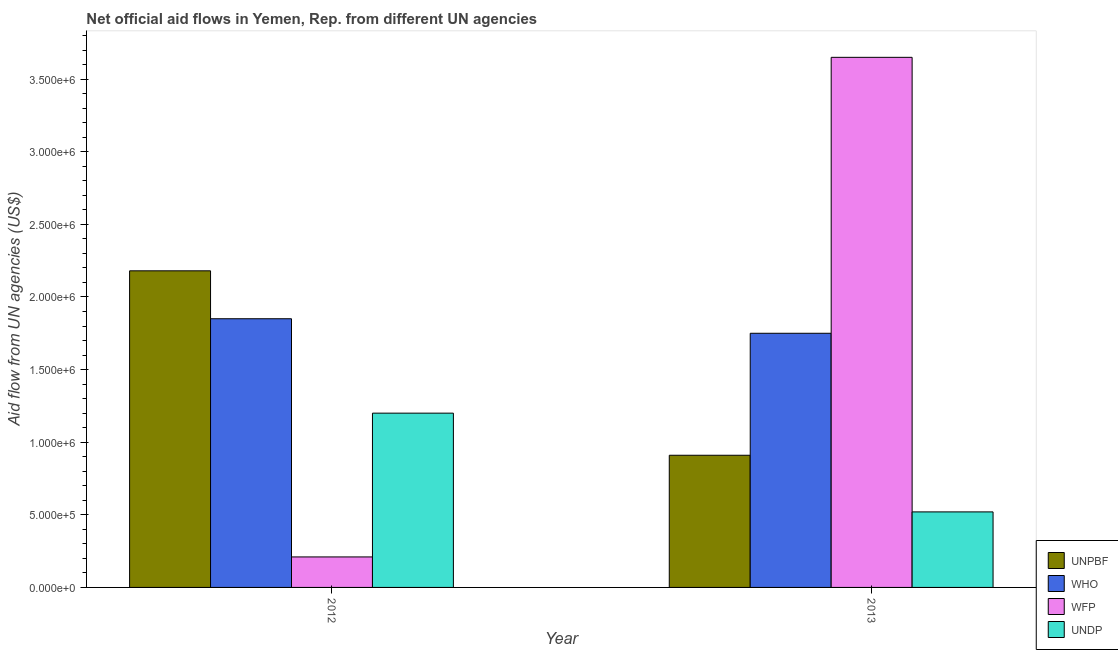How many different coloured bars are there?
Your answer should be compact. 4. Are the number of bars per tick equal to the number of legend labels?
Your answer should be very brief. Yes. Are the number of bars on each tick of the X-axis equal?
Your answer should be compact. Yes. How many bars are there on the 1st tick from the left?
Make the answer very short. 4. What is the label of the 1st group of bars from the left?
Provide a succinct answer. 2012. What is the amount of aid given by undp in 2012?
Provide a short and direct response. 1.20e+06. Across all years, what is the maximum amount of aid given by wfp?
Make the answer very short. 3.65e+06. Across all years, what is the minimum amount of aid given by who?
Offer a very short reply. 1.75e+06. In which year was the amount of aid given by who minimum?
Your answer should be compact. 2013. What is the total amount of aid given by who in the graph?
Ensure brevity in your answer.  3.60e+06. What is the difference between the amount of aid given by wfp in 2012 and that in 2013?
Offer a terse response. -3.44e+06. What is the difference between the amount of aid given by who in 2012 and the amount of aid given by undp in 2013?
Offer a terse response. 1.00e+05. What is the average amount of aid given by who per year?
Give a very brief answer. 1.80e+06. In how many years, is the amount of aid given by who greater than 1600000 US$?
Keep it short and to the point. 2. What is the ratio of the amount of aid given by unpbf in 2012 to that in 2013?
Your answer should be compact. 2.4. Is it the case that in every year, the sum of the amount of aid given by wfp and amount of aid given by unpbf is greater than the sum of amount of aid given by who and amount of aid given by undp?
Your answer should be very brief. No. What does the 2nd bar from the left in 2013 represents?
Provide a succinct answer. WHO. What does the 2nd bar from the right in 2012 represents?
Keep it short and to the point. WFP. Are all the bars in the graph horizontal?
Give a very brief answer. No. What is the difference between two consecutive major ticks on the Y-axis?
Make the answer very short. 5.00e+05. Are the values on the major ticks of Y-axis written in scientific E-notation?
Provide a short and direct response. Yes. Does the graph contain grids?
Ensure brevity in your answer.  No. Where does the legend appear in the graph?
Offer a very short reply. Bottom right. How are the legend labels stacked?
Offer a terse response. Vertical. What is the title of the graph?
Keep it short and to the point. Net official aid flows in Yemen, Rep. from different UN agencies. Does "Social equity" appear as one of the legend labels in the graph?
Offer a very short reply. No. What is the label or title of the X-axis?
Ensure brevity in your answer.  Year. What is the label or title of the Y-axis?
Ensure brevity in your answer.  Aid flow from UN agencies (US$). What is the Aid flow from UN agencies (US$) in UNPBF in 2012?
Offer a very short reply. 2.18e+06. What is the Aid flow from UN agencies (US$) of WHO in 2012?
Ensure brevity in your answer.  1.85e+06. What is the Aid flow from UN agencies (US$) in UNDP in 2012?
Keep it short and to the point. 1.20e+06. What is the Aid flow from UN agencies (US$) of UNPBF in 2013?
Provide a short and direct response. 9.10e+05. What is the Aid flow from UN agencies (US$) in WHO in 2013?
Provide a short and direct response. 1.75e+06. What is the Aid flow from UN agencies (US$) in WFP in 2013?
Give a very brief answer. 3.65e+06. What is the Aid flow from UN agencies (US$) of UNDP in 2013?
Your answer should be compact. 5.20e+05. Across all years, what is the maximum Aid flow from UN agencies (US$) of UNPBF?
Offer a very short reply. 2.18e+06. Across all years, what is the maximum Aid flow from UN agencies (US$) in WHO?
Give a very brief answer. 1.85e+06. Across all years, what is the maximum Aid flow from UN agencies (US$) in WFP?
Your answer should be very brief. 3.65e+06. Across all years, what is the maximum Aid flow from UN agencies (US$) in UNDP?
Make the answer very short. 1.20e+06. Across all years, what is the minimum Aid flow from UN agencies (US$) in UNPBF?
Provide a short and direct response. 9.10e+05. Across all years, what is the minimum Aid flow from UN agencies (US$) in WHO?
Ensure brevity in your answer.  1.75e+06. Across all years, what is the minimum Aid flow from UN agencies (US$) in WFP?
Your answer should be compact. 2.10e+05. Across all years, what is the minimum Aid flow from UN agencies (US$) in UNDP?
Make the answer very short. 5.20e+05. What is the total Aid flow from UN agencies (US$) of UNPBF in the graph?
Give a very brief answer. 3.09e+06. What is the total Aid flow from UN agencies (US$) of WHO in the graph?
Offer a very short reply. 3.60e+06. What is the total Aid flow from UN agencies (US$) in WFP in the graph?
Your answer should be very brief. 3.86e+06. What is the total Aid flow from UN agencies (US$) of UNDP in the graph?
Your response must be concise. 1.72e+06. What is the difference between the Aid flow from UN agencies (US$) in UNPBF in 2012 and that in 2013?
Provide a short and direct response. 1.27e+06. What is the difference between the Aid flow from UN agencies (US$) in WHO in 2012 and that in 2013?
Keep it short and to the point. 1.00e+05. What is the difference between the Aid flow from UN agencies (US$) of WFP in 2012 and that in 2013?
Your response must be concise. -3.44e+06. What is the difference between the Aid flow from UN agencies (US$) of UNDP in 2012 and that in 2013?
Ensure brevity in your answer.  6.80e+05. What is the difference between the Aid flow from UN agencies (US$) of UNPBF in 2012 and the Aid flow from UN agencies (US$) of WHO in 2013?
Offer a terse response. 4.30e+05. What is the difference between the Aid flow from UN agencies (US$) of UNPBF in 2012 and the Aid flow from UN agencies (US$) of WFP in 2013?
Your response must be concise. -1.47e+06. What is the difference between the Aid flow from UN agencies (US$) in UNPBF in 2012 and the Aid flow from UN agencies (US$) in UNDP in 2013?
Give a very brief answer. 1.66e+06. What is the difference between the Aid flow from UN agencies (US$) of WHO in 2012 and the Aid flow from UN agencies (US$) of WFP in 2013?
Your answer should be very brief. -1.80e+06. What is the difference between the Aid flow from UN agencies (US$) of WHO in 2012 and the Aid flow from UN agencies (US$) of UNDP in 2013?
Ensure brevity in your answer.  1.33e+06. What is the difference between the Aid flow from UN agencies (US$) in WFP in 2012 and the Aid flow from UN agencies (US$) in UNDP in 2013?
Offer a terse response. -3.10e+05. What is the average Aid flow from UN agencies (US$) in UNPBF per year?
Make the answer very short. 1.54e+06. What is the average Aid flow from UN agencies (US$) of WHO per year?
Offer a terse response. 1.80e+06. What is the average Aid flow from UN agencies (US$) of WFP per year?
Give a very brief answer. 1.93e+06. What is the average Aid flow from UN agencies (US$) in UNDP per year?
Provide a succinct answer. 8.60e+05. In the year 2012, what is the difference between the Aid flow from UN agencies (US$) of UNPBF and Aid flow from UN agencies (US$) of WHO?
Keep it short and to the point. 3.30e+05. In the year 2012, what is the difference between the Aid flow from UN agencies (US$) in UNPBF and Aid flow from UN agencies (US$) in WFP?
Give a very brief answer. 1.97e+06. In the year 2012, what is the difference between the Aid flow from UN agencies (US$) in UNPBF and Aid flow from UN agencies (US$) in UNDP?
Offer a very short reply. 9.80e+05. In the year 2012, what is the difference between the Aid flow from UN agencies (US$) in WHO and Aid flow from UN agencies (US$) in WFP?
Provide a succinct answer. 1.64e+06. In the year 2012, what is the difference between the Aid flow from UN agencies (US$) of WHO and Aid flow from UN agencies (US$) of UNDP?
Offer a very short reply. 6.50e+05. In the year 2012, what is the difference between the Aid flow from UN agencies (US$) in WFP and Aid flow from UN agencies (US$) in UNDP?
Ensure brevity in your answer.  -9.90e+05. In the year 2013, what is the difference between the Aid flow from UN agencies (US$) in UNPBF and Aid flow from UN agencies (US$) in WHO?
Make the answer very short. -8.40e+05. In the year 2013, what is the difference between the Aid flow from UN agencies (US$) in UNPBF and Aid flow from UN agencies (US$) in WFP?
Offer a very short reply. -2.74e+06. In the year 2013, what is the difference between the Aid flow from UN agencies (US$) in WHO and Aid flow from UN agencies (US$) in WFP?
Your response must be concise. -1.90e+06. In the year 2013, what is the difference between the Aid flow from UN agencies (US$) of WHO and Aid flow from UN agencies (US$) of UNDP?
Ensure brevity in your answer.  1.23e+06. In the year 2013, what is the difference between the Aid flow from UN agencies (US$) in WFP and Aid flow from UN agencies (US$) in UNDP?
Provide a short and direct response. 3.13e+06. What is the ratio of the Aid flow from UN agencies (US$) of UNPBF in 2012 to that in 2013?
Provide a short and direct response. 2.4. What is the ratio of the Aid flow from UN agencies (US$) in WHO in 2012 to that in 2013?
Give a very brief answer. 1.06. What is the ratio of the Aid flow from UN agencies (US$) in WFP in 2012 to that in 2013?
Provide a succinct answer. 0.06. What is the ratio of the Aid flow from UN agencies (US$) of UNDP in 2012 to that in 2013?
Offer a terse response. 2.31. What is the difference between the highest and the second highest Aid flow from UN agencies (US$) in UNPBF?
Your answer should be very brief. 1.27e+06. What is the difference between the highest and the second highest Aid flow from UN agencies (US$) of WFP?
Your response must be concise. 3.44e+06. What is the difference between the highest and the second highest Aid flow from UN agencies (US$) in UNDP?
Provide a short and direct response. 6.80e+05. What is the difference between the highest and the lowest Aid flow from UN agencies (US$) of UNPBF?
Keep it short and to the point. 1.27e+06. What is the difference between the highest and the lowest Aid flow from UN agencies (US$) in WFP?
Your answer should be very brief. 3.44e+06. What is the difference between the highest and the lowest Aid flow from UN agencies (US$) of UNDP?
Ensure brevity in your answer.  6.80e+05. 